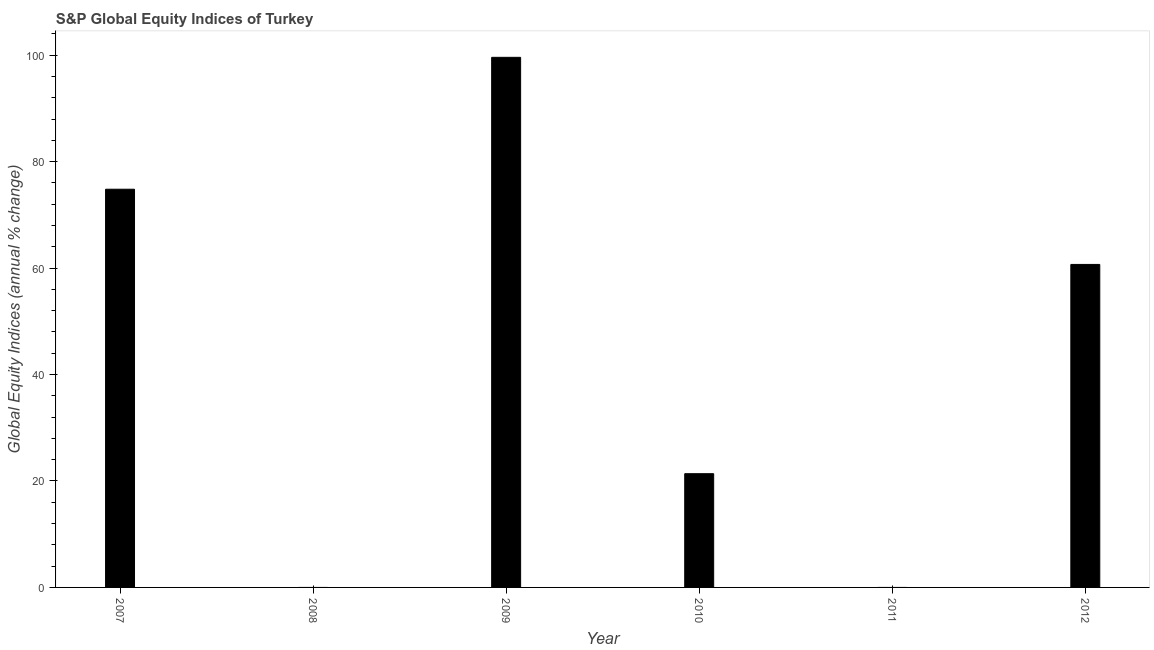Does the graph contain any zero values?
Make the answer very short. Yes. What is the title of the graph?
Make the answer very short. S&P Global Equity Indices of Turkey. What is the label or title of the Y-axis?
Your answer should be very brief. Global Equity Indices (annual % change). What is the s&p global equity indices in 2010?
Offer a terse response. 21.37. Across all years, what is the maximum s&p global equity indices?
Your response must be concise. 99.6. Across all years, what is the minimum s&p global equity indices?
Give a very brief answer. 0. What is the sum of the s&p global equity indices?
Provide a succinct answer. 256.48. What is the difference between the s&p global equity indices in 2009 and 2010?
Keep it short and to the point. 78.24. What is the average s&p global equity indices per year?
Provide a succinct answer. 42.75. What is the median s&p global equity indices?
Your answer should be compact. 41.03. What is the ratio of the s&p global equity indices in 2009 to that in 2010?
Ensure brevity in your answer.  4.66. Is the difference between the s&p global equity indices in 2010 and 2012 greater than the difference between any two years?
Your answer should be very brief. No. What is the difference between the highest and the second highest s&p global equity indices?
Offer a very short reply. 24.78. Is the sum of the s&p global equity indices in 2009 and 2010 greater than the maximum s&p global equity indices across all years?
Make the answer very short. Yes. What is the difference between the highest and the lowest s&p global equity indices?
Your response must be concise. 99.6. In how many years, is the s&p global equity indices greater than the average s&p global equity indices taken over all years?
Your response must be concise. 3. How many bars are there?
Keep it short and to the point. 4. How many years are there in the graph?
Your answer should be compact. 6. What is the difference between two consecutive major ticks on the Y-axis?
Give a very brief answer. 20. What is the Global Equity Indices (annual % change) of 2007?
Give a very brief answer. 74.82. What is the Global Equity Indices (annual % change) in 2008?
Offer a very short reply. 0. What is the Global Equity Indices (annual % change) of 2009?
Offer a very short reply. 99.6. What is the Global Equity Indices (annual % change) of 2010?
Ensure brevity in your answer.  21.37. What is the Global Equity Indices (annual % change) of 2011?
Make the answer very short. 0. What is the Global Equity Indices (annual % change) in 2012?
Give a very brief answer. 60.69. What is the difference between the Global Equity Indices (annual % change) in 2007 and 2009?
Provide a succinct answer. -24.78. What is the difference between the Global Equity Indices (annual % change) in 2007 and 2010?
Give a very brief answer. 53.45. What is the difference between the Global Equity Indices (annual % change) in 2007 and 2012?
Provide a succinct answer. 14.13. What is the difference between the Global Equity Indices (annual % change) in 2009 and 2010?
Your answer should be very brief. 78.24. What is the difference between the Global Equity Indices (annual % change) in 2009 and 2012?
Ensure brevity in your answer.  38.92. What is the difference between the Global Equity Indices (annual % change) in 2010 and 2012?
Your answer should be compact. -39.32. What is the ratio of the Global Equity Indices (annual % change) in 2007 to that in 2009?
Offer a terse response. 0.75. What is the ratio of the Global Equity Indices (annual % change) in 2007 to that in 2010?
Provide a short and direct response. 3.5. What is the ratio of the Global Equity Indices (annual % change) in 2007 to that in 2012?
Your response must be concise. 1.23. What is the ratio of the Global Equity Indices (annual % change) in 2009 to that in 2010?
Your answer should be very brief. 4.66. What is the ratio of the Global Equity Indices (annual % change) in 2009 to that in 2012?
Ensure brevity in your answer.  1.64. What is the ratio of the Global Equity Indices (annual % change) in 2010 to that in 2012?
Your answer should be compact. 0.35. 